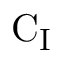Convert formula to latex. <formula><loc_0><loc_0><loc_500><loc_500>C _ { I }</formula> 